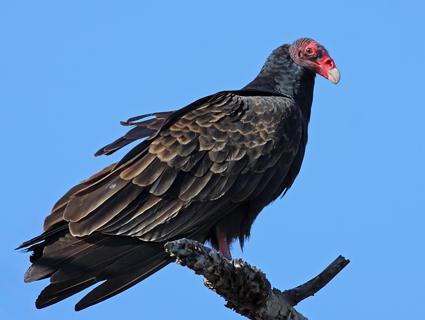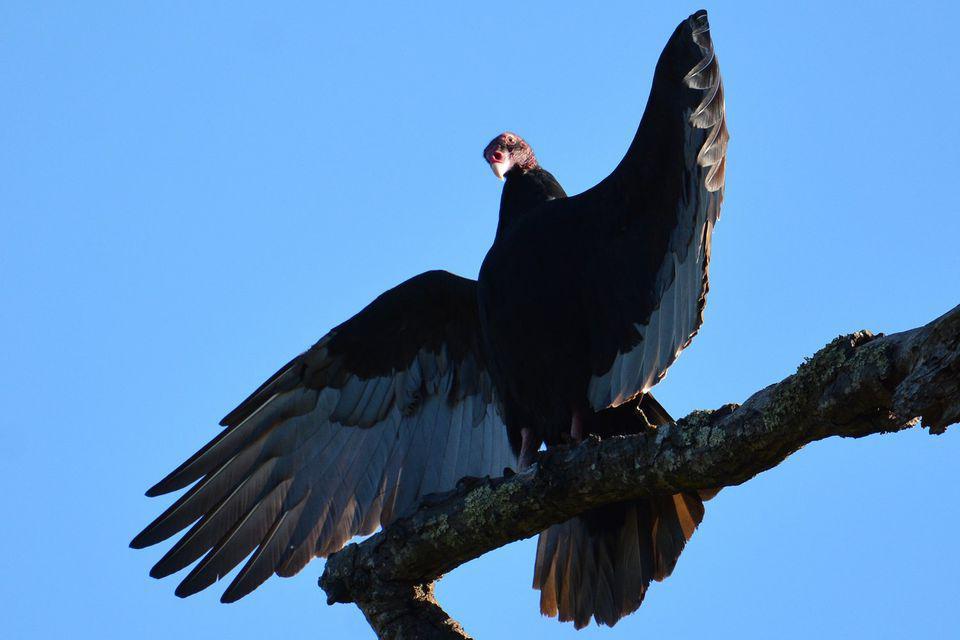The first image is the image on the left, the second image is the image on the right. Considering the images on both sides, is "Both turkey vultures are standing on a tree branch" valid? Answer yes or no. Yes. The first image is the image on the left, the second image is the image on the right. Analyze the images presented: Is the assertion "There is one large bird with black and white feathers that has its wings spread." valid? Answer yes or no. Yes. 